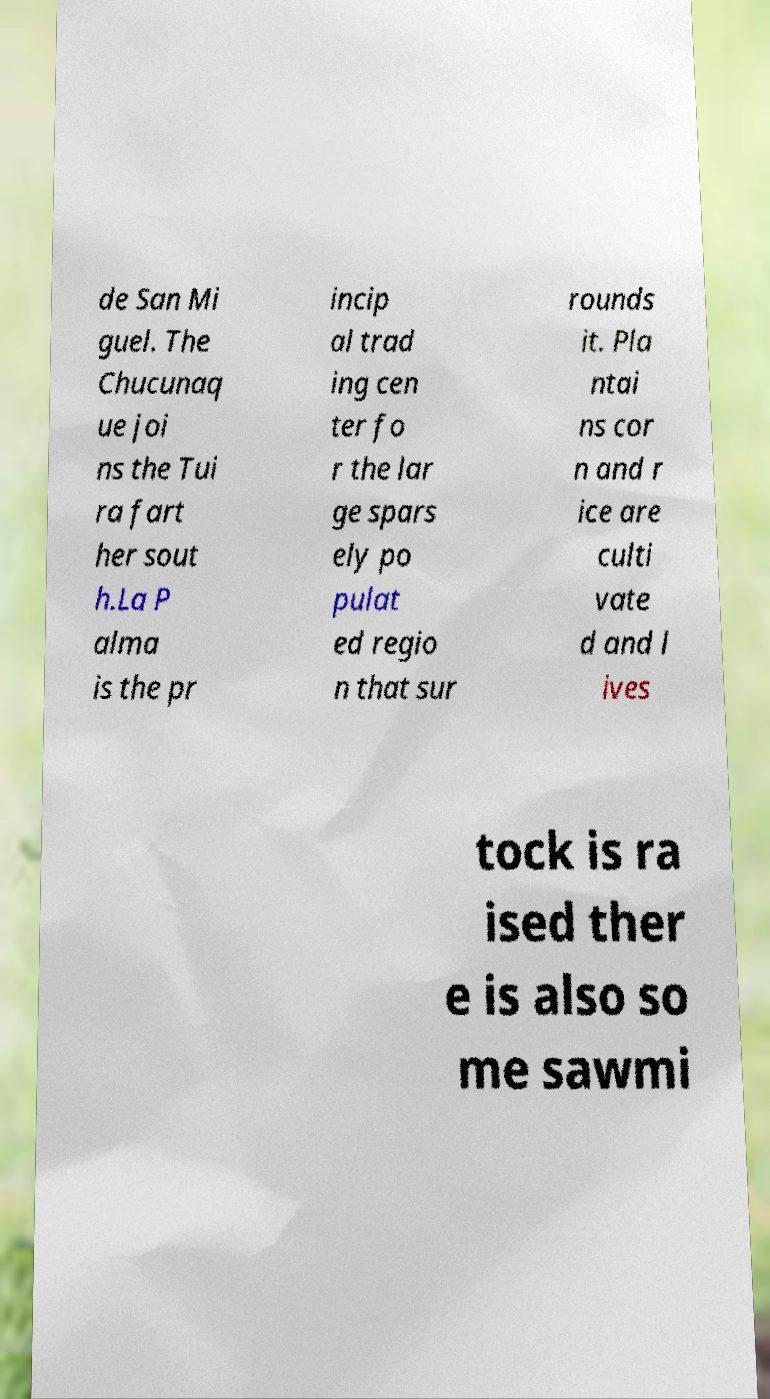Can you accurately transcribe the text from the provided image for me? de San Mi guel. The Chucunaq ue joi ns the Tui ra fart her sout h.La P alma is the pr incip al trad ing cen ter fo r the lar ge spars ely po pulat ed regio n that sur rounds it. Pla ntai ns cor n and r ice are culti vate d and l ives tock is ra ised ther e is also so me sawmi 